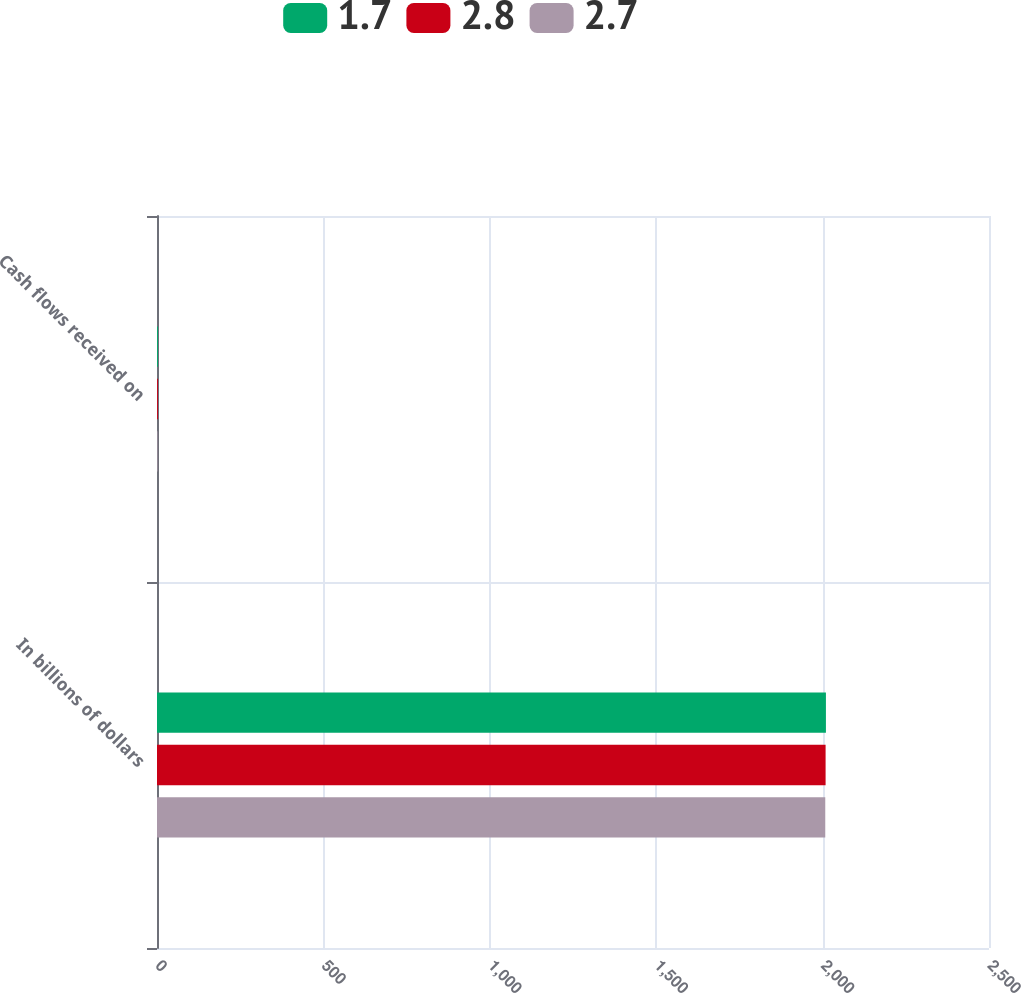Convert chart to OTSL. <chart><loc_0><loc_0><loc_500><loc_500><stacked_bar_chart><ecel><fcel>In billions of dollars<fcel>Cash flows received on<nl><fcel>1.7<fcel>2010<fcel>2.8<nl><fcel>2.8<fcel>2009<fcel>2.7<nl><fcel>2.7<fcel>2008<fcel>1.7<nl></chart> 